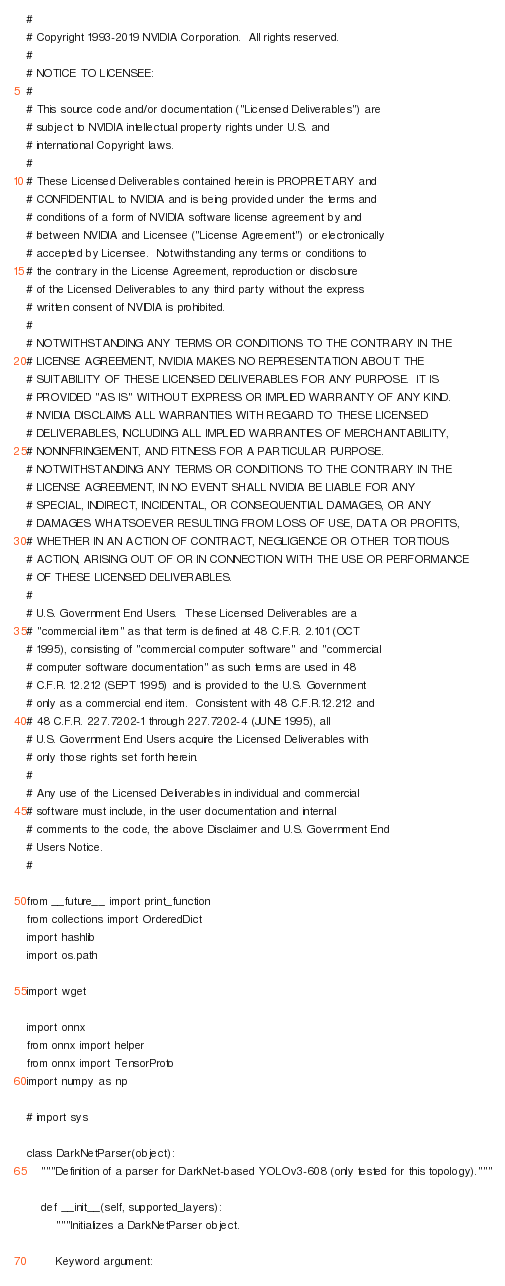Convert code to text. <code><loc_0><loc_0><loc_500><loc_500><_Python_>#
# Copyright 1993-2019 NVIDIA Corporation.  All rights reserved.
#
# NOTICE TO LICENSEE:
#
# This source code and/or documentation ("Licensed Deliverables") are
# subject to NVIDIA intellectual property rights under U.S. and
# international Copyright laws.
#
# These Licensed Deliverables contained herein is PROPRIETARY and
# CONFIDENTIAL to NVIDIA and is being provided under the terms and
# conditions of a form of NVIDIA software license agreement by and
# between NVIDIA and Licensee ("License Agreement") or electronically
# accepted by Licensee.  Notwithstanding any terms or conditions to
# the contrary in the License Agreement, reproduction or disclosure
# of the Licensed Deliverables to any third party without the express
# written consent of NVIDIA is prohibited.
#
# NOTWITHSTANDING ANY TERMS OR CONDITIONS TO THE CONTRARY IN THE
# LICENSE AGREEMENT, NVIDIA MAKES NO REPRESENTATION ABOUT THE
# SUITABILITY OF THESE LICENSED DELIVERABLES FOR ANY PURPOSE.  IT IS
# PROVIDED "AS IS" WITHOUT EXPRESS OR IMPLIED WARRANTY OF ANY KIND.
# NVIDIA DISCLAIMS ALL WARRANTIES WITH REGARD TO THESE LICENSED
# DELIVERABLES, INCLUDING ALL IMPLIED WARRANTIES OF MERCHANTABILITY,
# NONINFRINGEMENT, AND FITNESS FOR A PARTICULAR PURPOSE.
# NOTWITHSTANDING ANY TERMS OR CONDITIONS TO THE CONTRARY IN THE
# LICENSE AGREEMENT, IN NO EVENT SHALL NVIDIA BE LIABLE FOR ANY
# SPECIAL, INDIRECT, INCIDENTAL, OR CONSEQUENTIAL DAMAGES, OR ANY
# DAMAGES WHATSOEVER RESULTING FROM LOSS OF USE, DATA OR PROFITS,
# WHETHER IN AN ACTION OF CONTRACT, NEGLIGENCE OR OTHER TORTIOUS
# ACTION, ARISING OUT OF OR IN CONNECTION WITH THE USE OR PERFORMANCE
# OF THESE LICENSED DELIVERABLES.
#
# U.S. Government End Users.  These Licensed Deliverables are a
# "commercial item" as that term is defined at 48 C.F.R. 2.101 (OCT
# 1995), consisting of "commercial computer software" and "commercial
# computer software documentation" as such terms are used in 48
# C.F.R. 12.212 (SEPT 1995) and is provided to the U.S. Government
# only as a commercial end item.  Consistent with 48 C.F.R.12.212 and
# 48 C.F.R. 227.7202-1 through 227.7202-4 (JUNE 1995), all
# U.S. Government End Users acquire the Licensed Deliverables with
# only those rights set forth herein.
#
# Any use of the Licensed Deliverables in individual and commercial
# software must include, in the user documentation and internal
# comments to the code, the above Disclaimer and U.S. Government End
# Users Notice.
#

from __future__ import print_function
from collections import OrderedDict
import hashlib
import os.path

import wget

import onnx
from onnx import helper
from onnx import TensorProto
import numpy as np

# import sys

class DarkNetParser(object):
    """Definition of a parser for DarkNet-based YOLOv3-608 (only tested for this topology)."""

    def __init__(self, supported_layers):
        """Initializes a DarkNetParser object.

        Keyword argument:</code> 